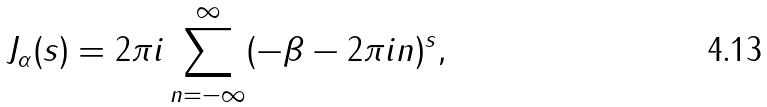Convert formula to latex. <formula><loc_0><loc_0><loc_500><loc_500>J _ { \alpha } ( s ) = 2 \pi i \sum _ { n = - \infty } ^ { \infty } ( - \beta - 2 \pi i n ) ^ { s } ,</formula> 